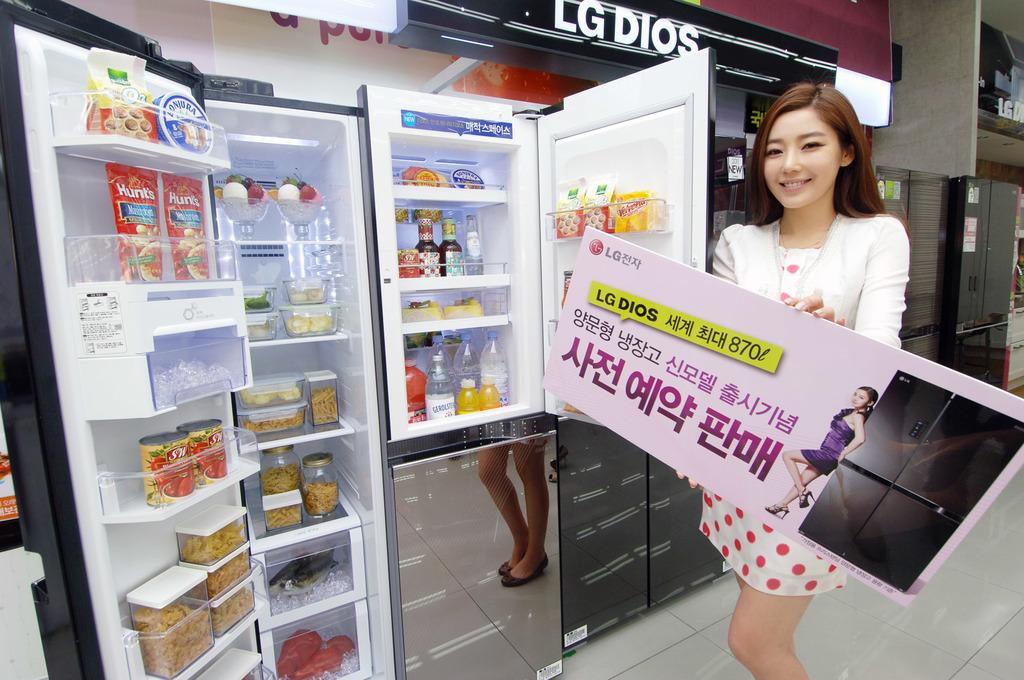Is this an lg product?
Your response must be concise. Yes. What is the name of the product?
Ensure brevity in your answer.  Lg dios. 